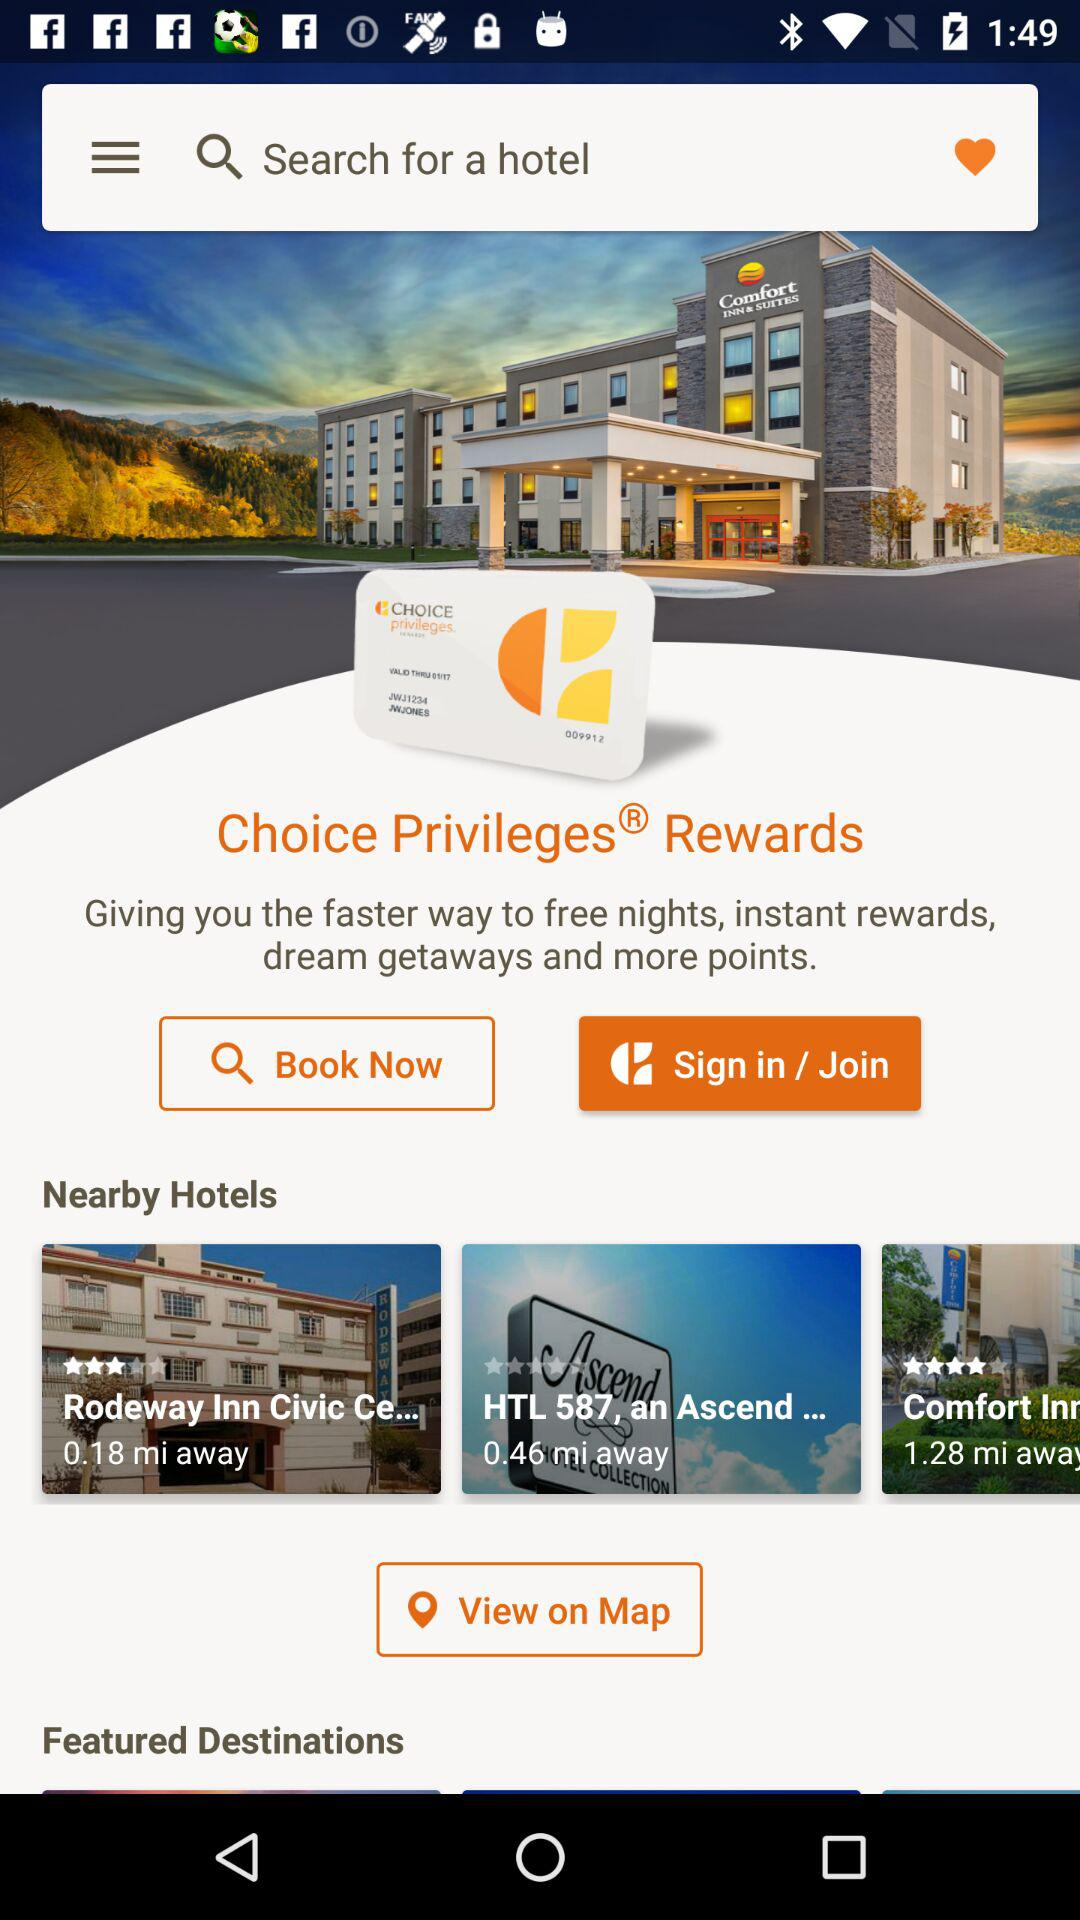What is the rating for the hotel "Rodeway Inn Civic Ce..."? The rating is 3 stars. 